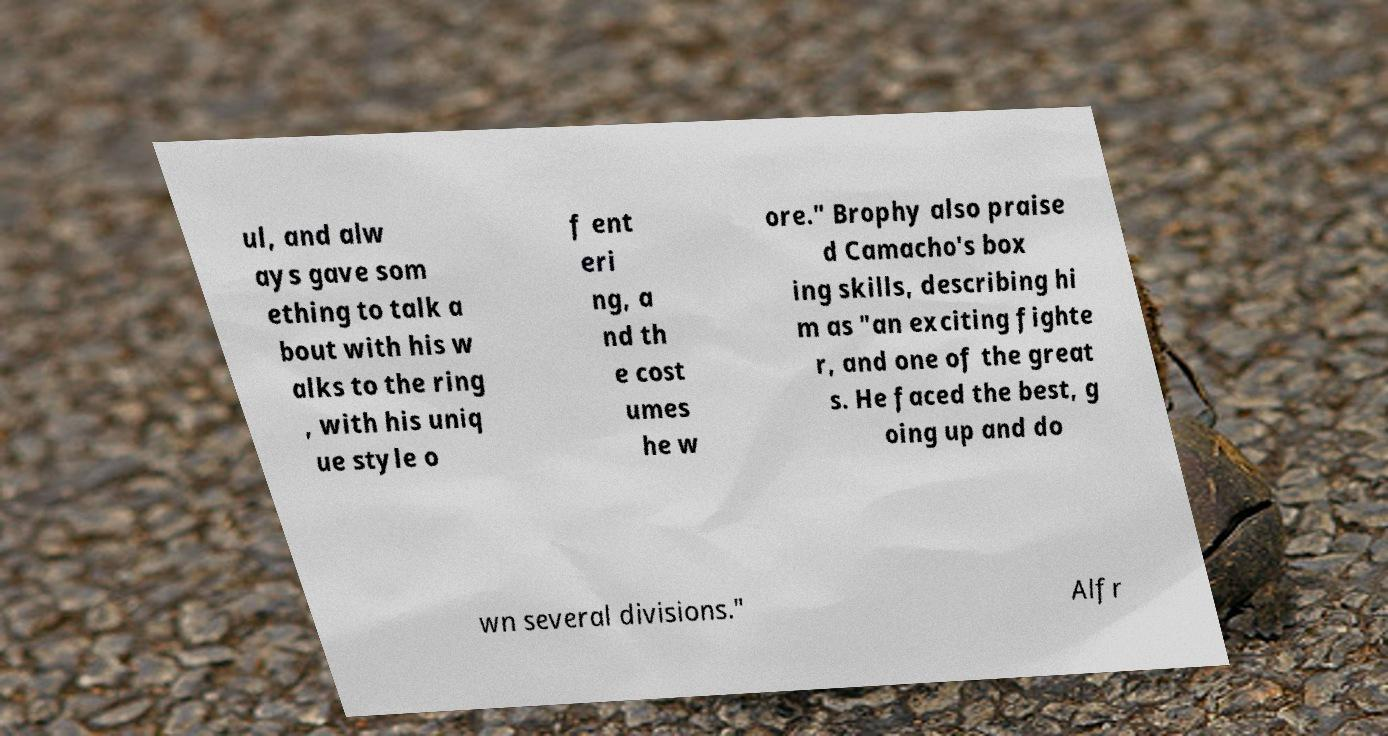Could you assist in decoding the text presented in this image and type it out clearly? ul, and alw ays gave som ething to talk a bout with his w alks to the ring , with his uniq ue style o f ent eri ng, a nd th e cost umes he w ore." Brophy also praise d Camacho's box ing skills, describing hi m as "an exciting fighte r, and one of the great s. He faced the best, g oing up and do wn several divisions." Alfr 